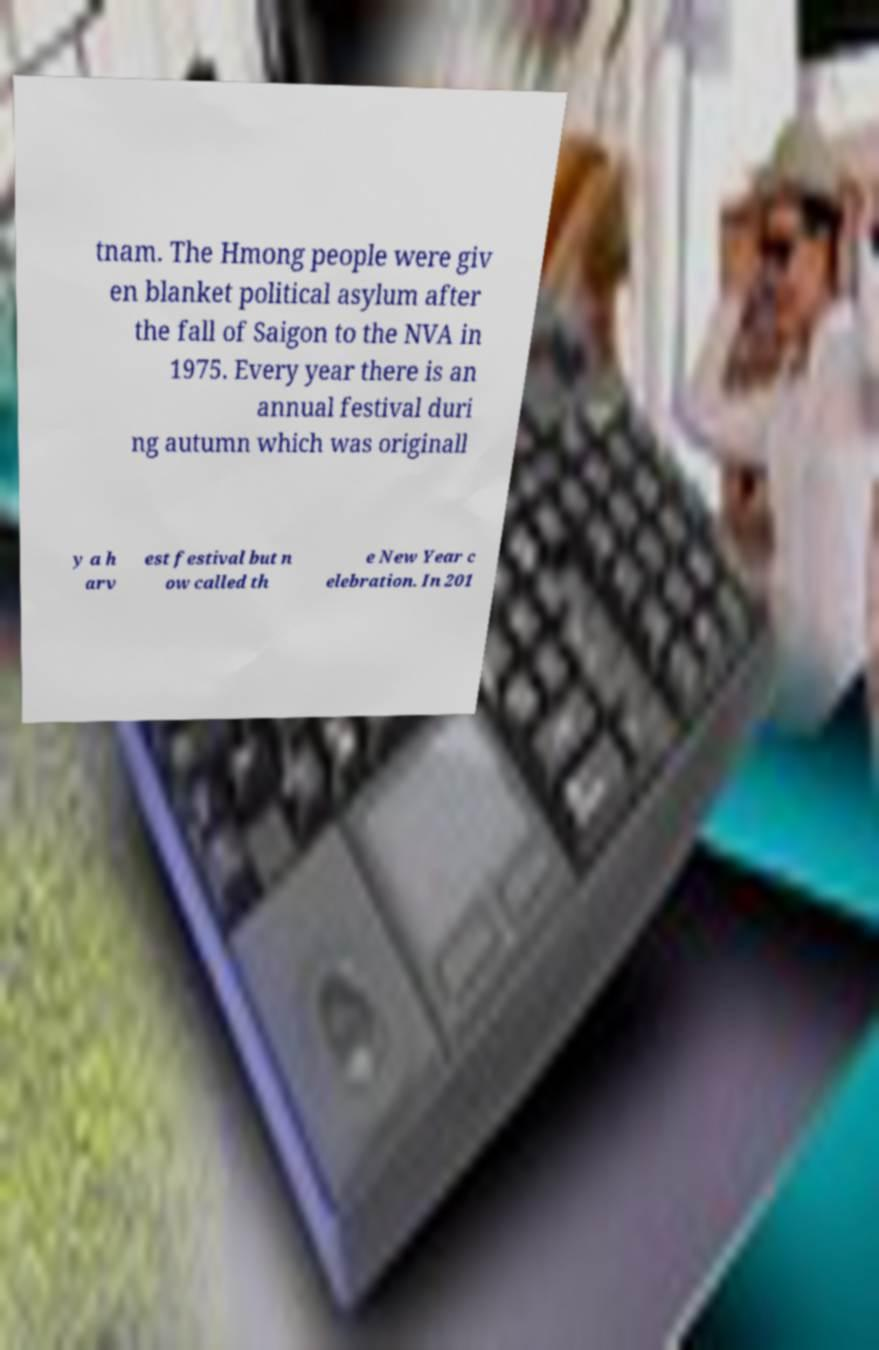I need the written content from this picture converted into text. Can you do that? tnam. The Hmong people were giv en blanket political asylum after the fall of Saigon to the NVA in 1975. Every year there is an annual festival duri ng autumn which was originall y a h arv est festival but n ow called th e New Year c elebration. In 201 